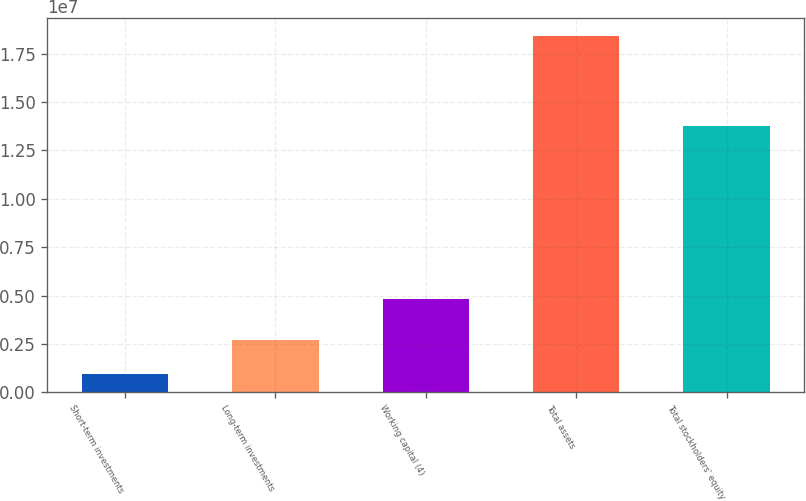Convert chart to OTSL. <chart><loc_0><loc_0><loc_500><loc_500><bar_chart><fcel>Short-term investments<fcel>Long-term investments<fcel>Working capital (4)<fcel>Total assets<fcel>Total stockholders' equity<nl><fcel>943986<fcel>2.69042e+06<fcel>4.81824e+06<fcel>1.84083e+07<fcel>1.37876e+07<nl></chart> 